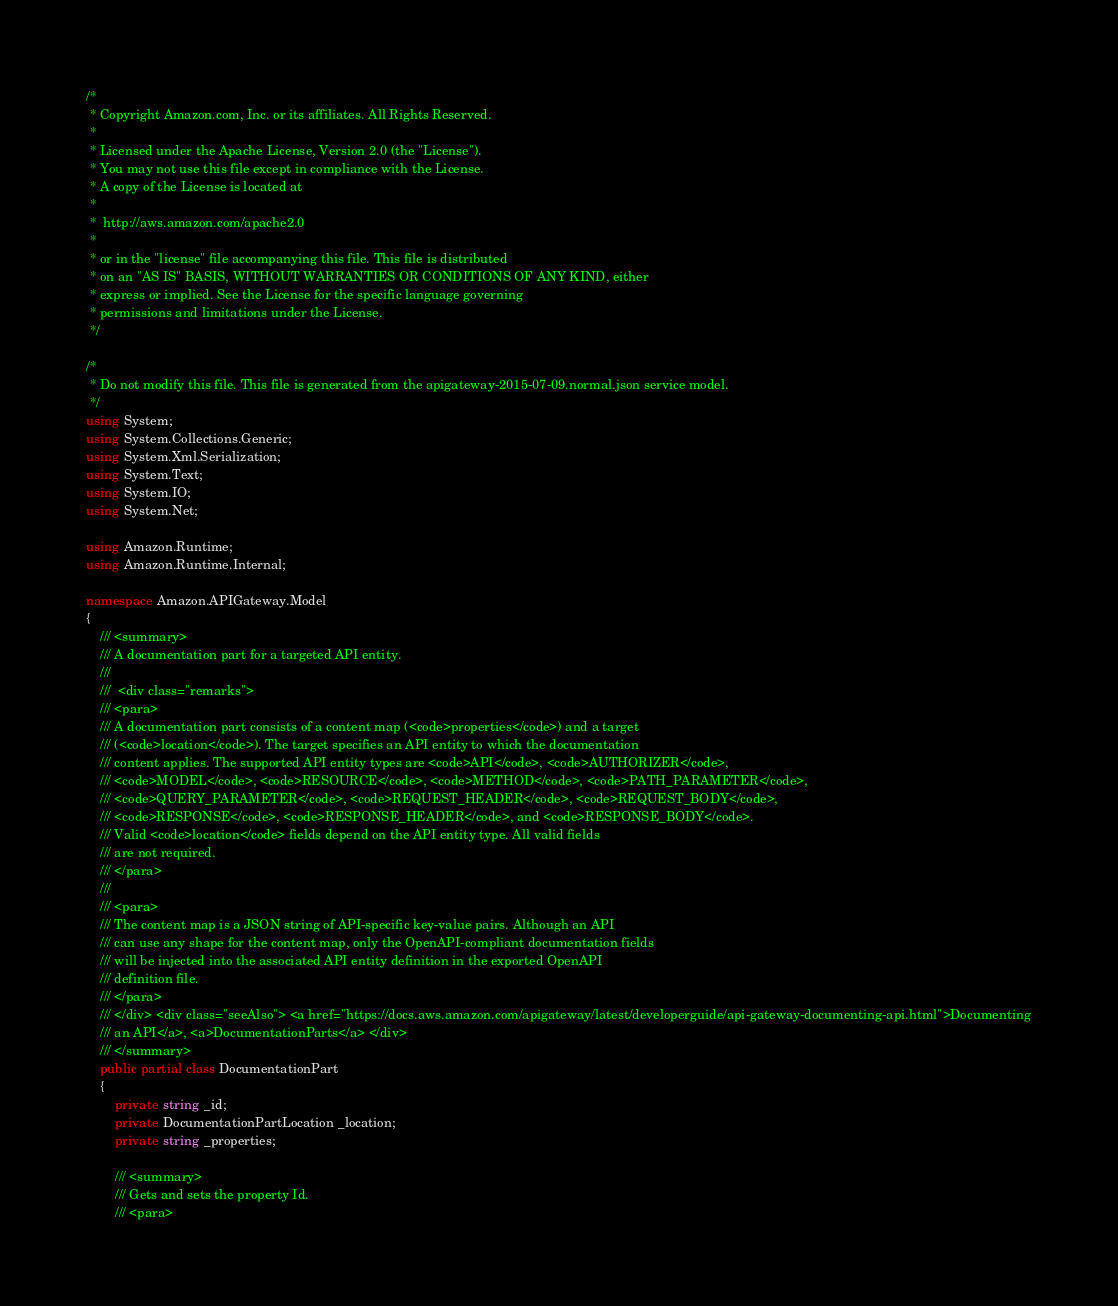Convert code to text. <code><loc_0><loc_0><loc_500><loc_500><_C#_>/*
 * Copyright Amazon.com, Inc. or its affiliates. All Rights Reserved.
 * 
 * Licensed under the Apache License, Version 2.0 (the "License").
 * You may not use this file except in compliance with the License.
 * A copy of the License is located at
 * 
 *  http://aws.amazon.com/apache2.0
 * 
 * or in the "license" file accompanying this file. This file is distributed
 * on an "AS IS" BASIS, WITHOUT WARRANTIES OR CONDITIONS OF ANY KIND, either
 * express or implied. See the License for the specific language governing
 * permissions and limitations under the License.
 */

/*
 * Do not modify this file. This file is generated from the apigateway-2015-07-09.normal.json service model.
 */
using System;
using System.Collections.Generic;
using System.Xml.Serialization;
using System.Text;
using System.IO;
using System.Net;

using Amazon.Runtime;
using Amazon.Runtime.Internal;

namespace Amazon.APIGateway.Model
{
    /// <summary>
    /// A documentation part for a targeted API entity.
    /// 
    ///  <div class="remarks"> 
    /// <para>
    /// A documentation part consists of a content map (<code>properties</code>) and a target
    /// (<code>location</code>). The target specifies an API entity to which the documentation
    /// content applies. The supported API entity types are <code>API</code>, <code>AUTHORIZER</code>,
    /// <code>MODEL</code>, <code>RESOURCE</code>, <code>METHOD</code>, <code>PATH_PARAMETER</code>,
    /// <code>QUERY_PARAMETER</code>, <code>REQUEST_HEADER</code>, <code>REQUEST_BODY</code>,
    /// <code>RESPONSE</code>, <code>RESPONSE_HEADER</code>, and <code>RESPONSE_BODY</code>.
    /// Valid <code>location</code> fields depend on the API entity type. All valid fields
    /// are not required.
    /// </para>
    ///  
    /// <para>
    /// The content map is a JSON string of API-specific key-value pairs. Although an API
    /// can use any shape for the content map, only the OpenAPI-compliant documentation fields
    /// will be injected into the associated API entity definition in the exported OpenAPI
    /// definition file.
    /// </para>
    /// </div> <div class="seeAlso"> <a href="https://docs.aws.amazon.com/apigateway/latest/developerguide/api-gateway-documenting-api.html">Documenting
    /// an API</a>, <a>DocumentationParts</a> </div>
    /// </summary>
    public partial class DocumentationPart
    {
        private string _id;
        private DocumentationPartLocation _location;
        private string _properties;

        /// <summary>
        /// Gets and sets the property Id. 
        /// <para></code> 